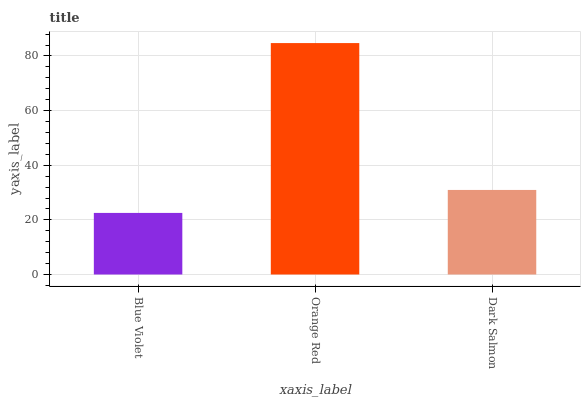Is Blue Violet the minimum?
Answer yes or no. Yes. Is Orange Red the maximum?
Answer yes or no. Yes. Is Dark Salmon the minimum?
Answer yes or no. No. Is Dark Salmon the maximum?
Answer yes or no. No. Is Orange Red greater than Dark Salmon?
Answer yes or no. Yes. Is Dark Salmon less than Orange Red?
Answer yes or no. Yes. Is Dark Salmon greater than Orange Red?
Answer yes or no. No. Is Orange Red less than Dark Salmon?
Answer yes or no. No. Is Dark Salmon the high median?
Answer yes or no. Yes. Is Dark Salmon the low median?
Answer yes or no. Yes. Is Orange Red the high median?
Answer yes or no. No. Is Orange Red the low median?
Answer yes or no. No. 